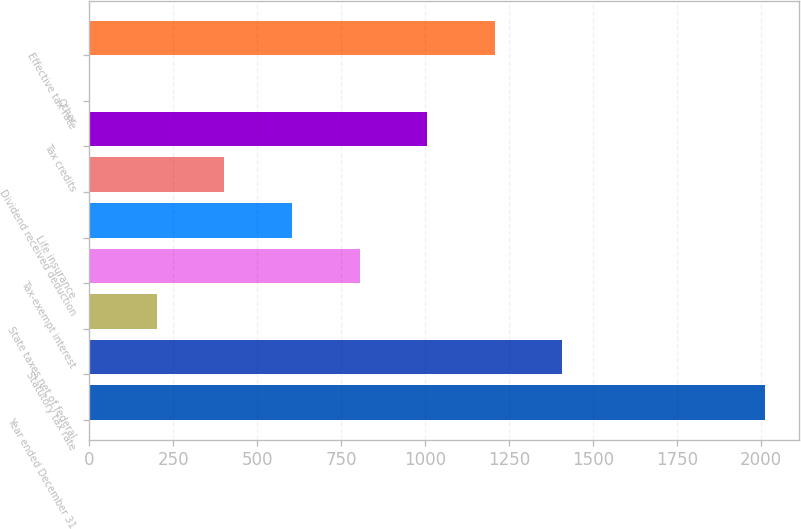Convert chart to OTSL. <chart><loc_0><loc_0><loc_500><loc_500><bar_chart><fcel>Year ended December 31<fcel>Statutory tax rate<fcel>State taxes net of federal<fcel>Tax-exempt interest<fcel>Life insurance<fcel>Dividend received deduction<fcel>Tax credits<fcel>Other<fcel>Effective tax rate<nl><fcel>2012<fcel>1408.55<fcel>201.65<fcel>805.1<fcel>603.95<fcel>402.8<fcel>1006.25<fcel>0.5<fcel>1207.4<nl></chart> 